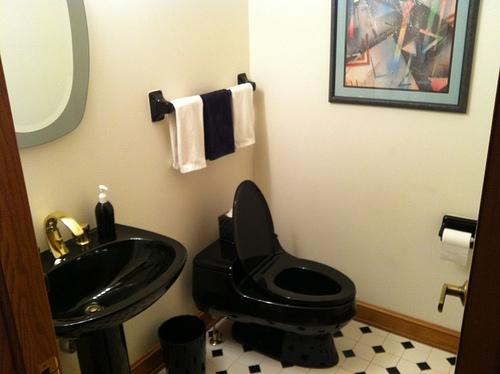Count how many towels are hanging in the bathroom and describe the arrangement. There are three towels hanging in the bathroom: two white towels with a black towel in the middle. What objects can be found on the towel rack? The towel rack has two white towels and one black towel. What is the color of the toilet and what is its state? The toilet is black, with the lid up, and a tissue box on the tank. What is unique about the pattern found on the bathroom floor? The bathroom floor has a checkered pattern with alternating black and white tiles. What is the design, shape, and material of the mirror in this bathroom? The mirror is a silver-framed oval-shaped mirror. What type of art is hanging in the bathroom? The artwork in the bathroom is an abstract piece in a black frame. Where can you find the gold-colored element in this image and what is it? The gold-colored element is a faucet, which can be found on the black sink. Enumerate the objects found in the bathroom that are black and shiny. The objects that are black and shiny are the toilet, sink, waste basket, soap dispenser, toilet paper dispenser, and towel rack. How would you describe the flooring in this image? The floor is made of checkered tile with black and white squares. Identify the object positioned between the sink and the toilet. There is a black trash can positioned between the sink and the toilet. 